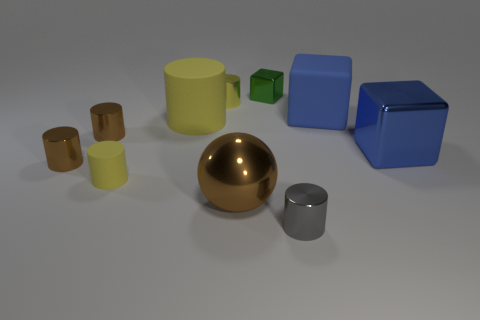Subtract all tiny blocks. How many blocks are left? 2 Subtract 1 blocks. How many blocks are left? 2 Subtract all yellow cubes. How many brown cylinders are left? 2 Subtract all cylinders. How many objects are left? 4 Subtract all blue blocks. How many blocks are left? 1 Subtract 0 purple cylinders. How many objects are left? 10 Subtract all gray cubes. Subtract all red cylinders. How many cubes are left? 3 Subtract all small blue balls. Subtract all small shiny cylinders. How many objects are left? 6 Add 9 tiny gray shiny cylinders. How many tiny gray shiny cylinders are left? 10 Add 2 green metal objects. How many green metal objects exist? 3 